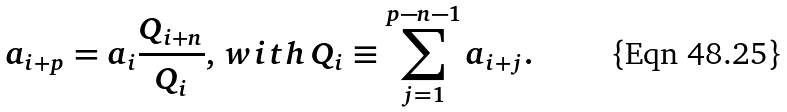<formula> <loc_0><loc_0><loc_500><loc_500>a _ { i + p } = a _ { i } \frac { Q _ { i + n } } { Q _ { i } } , \, w i t h \, Q _ { i } \equiv \sum _ { j = 1 } ^ { p - n - 1 } a _ { i + j } .</formula> 